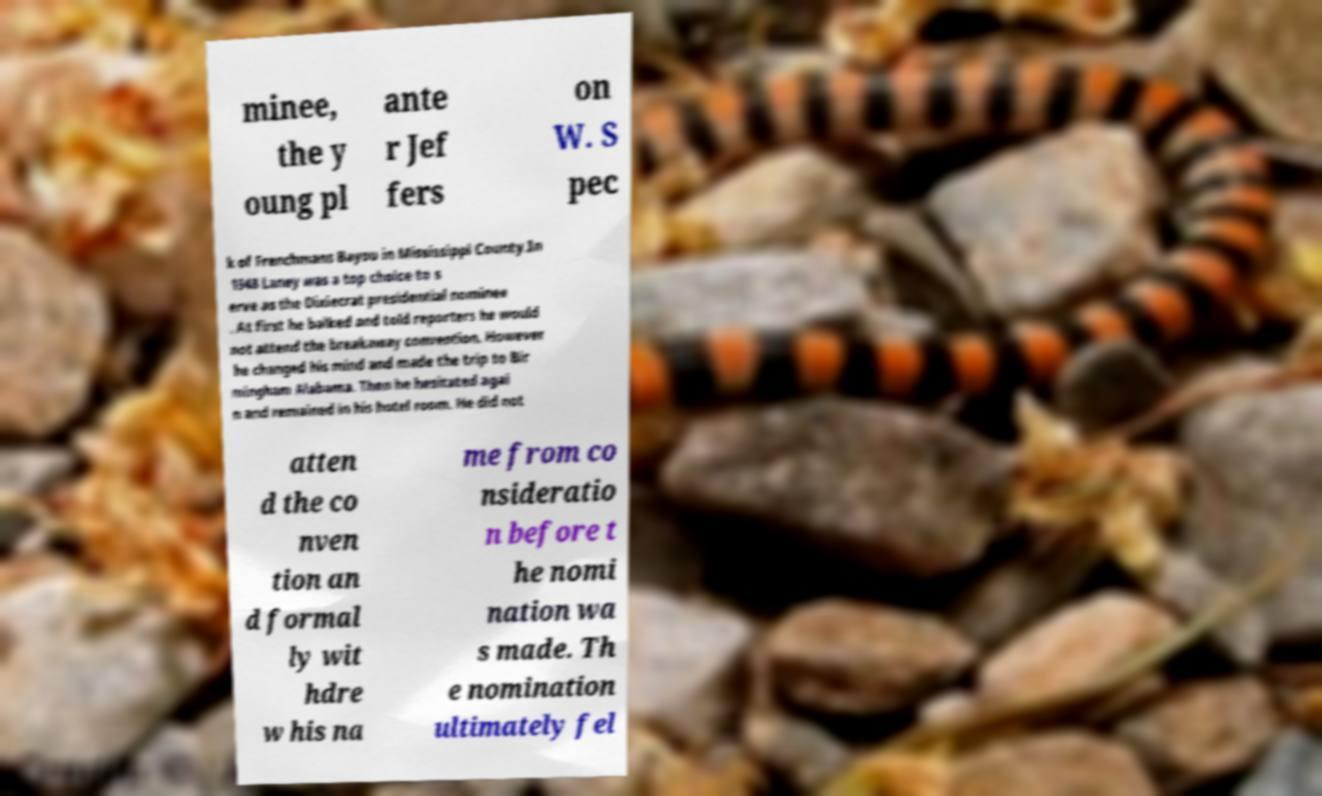Please identify and transcribe the text found in this image. minee, the y oung pl ante r Jef fers on W. S pec k of Frenchmans Bayou in Mississippi County.In 1948 Laney was a top choice to s erve as the Dixiecrat presidential nominee . At first he balked and told reporters he would not attend the breakaway convention. However he changed his mind and made the trip to Bir mingham Alabama. Then he hesitated agai n and remained in his hotel room. He did not atten d the co nven tion an d formal ly wit hdre w his na me from co nsideratio n before t he nomi nation wa s made. Th e nomination ultimately fel 